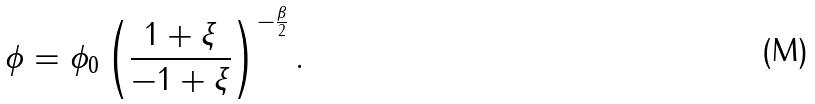<formula> <loc_0><loc_0><loc_500><loc_500>\phi = \phi _ { 0 } \left ( \frac { 1 + \xi } { - 1 + \xi } \right ) ^ { - \frac { \beta } { 2 } } .</formula> 